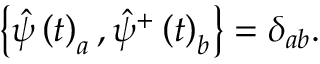Convert formula to latex. <formula><loc_0><loc_0><loc_500><loc_500>\left \{ \hat { \psi } \left ( t \right ) _ { a } , \hat { \psi } ^ { + } \left ( t \right ) _ { b } \right \} = \delta _ { a b } .</formula> 